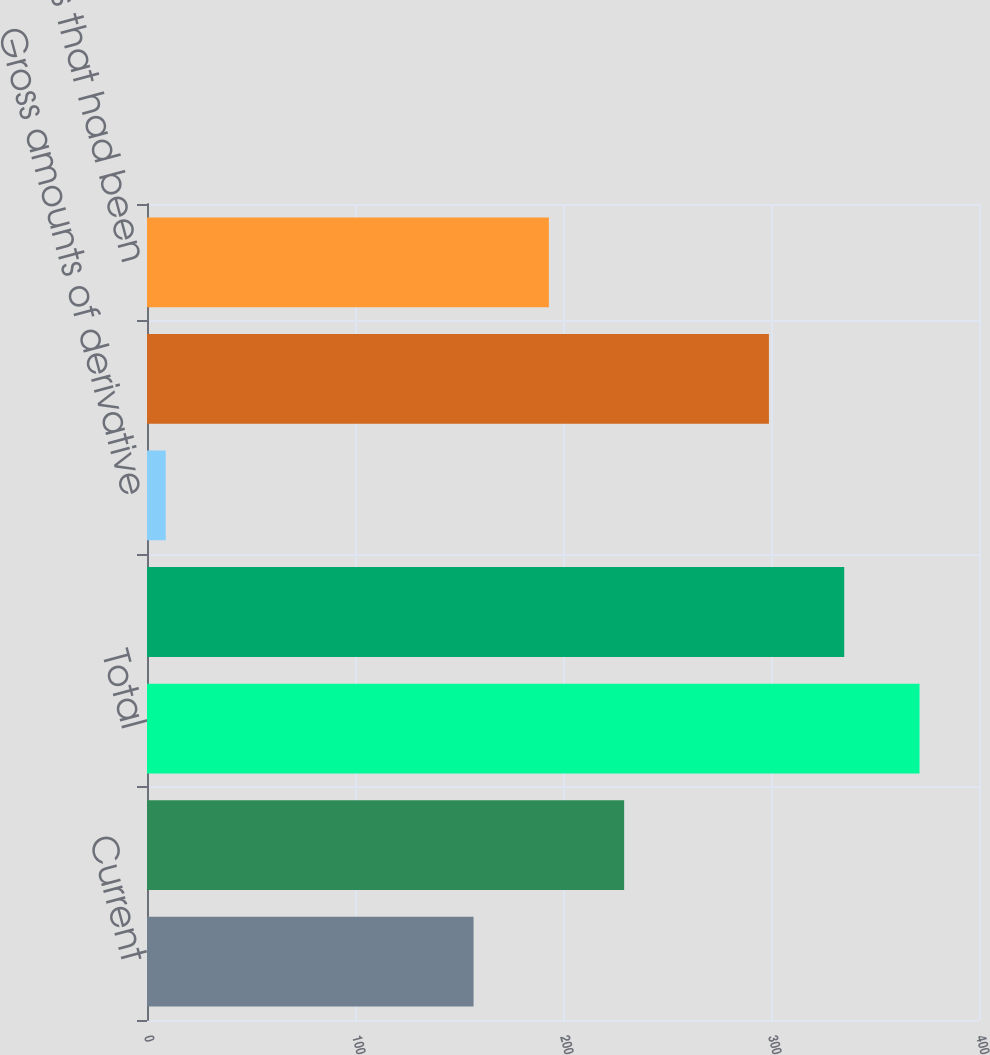Convert chart. <chart><loc_0><loc_0><loc_500><loc_500><bar_chart><fcel>Current<fcel>Noncurrent<fcel>Total<fcel>Gross amounts recognized in<fcel>Gross amounts of derivative<fcel>Net amount<fcel>Other balances that had been<nl><fcel>157<fcel>229.4<fcel>371.4<fcel>335.2<fcel>9<fcel>299<fcel>193.2<nl></chart> 